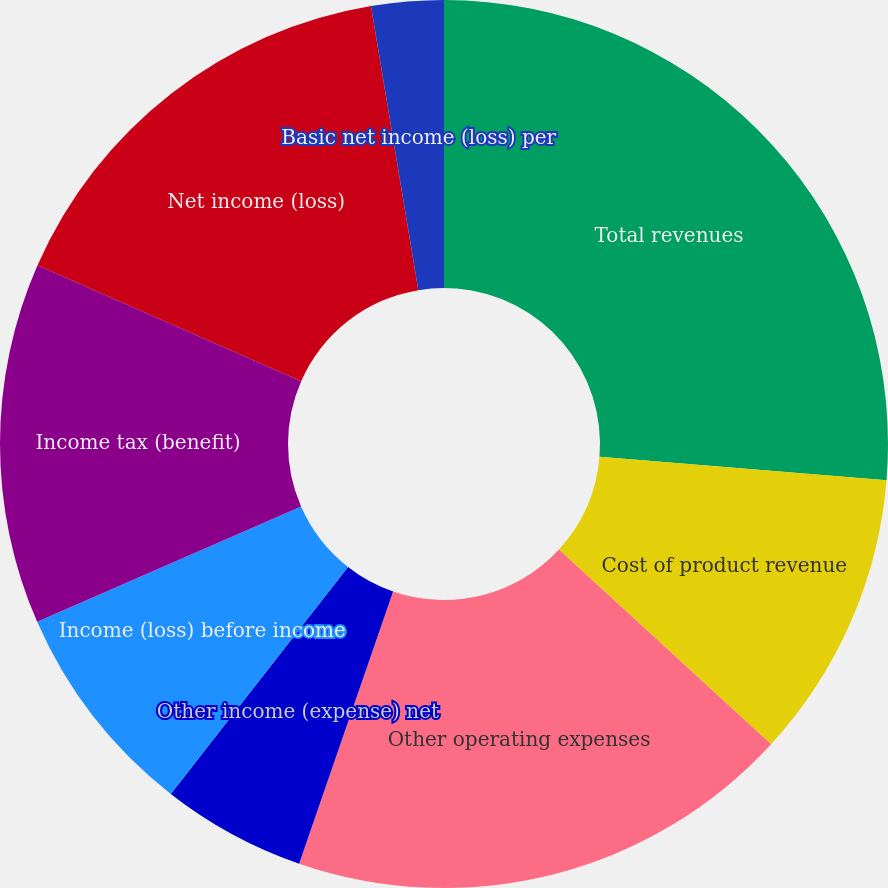Convert chart to OTSL. <chart><loc_0><loc_0><loc_500><loc_500><pie_chart><fcel>Total revenues<fcel>Cost of product revenue<fcel>Other operating expenses<fcel>Other income (expense) net<fcel>Income (loss) before income<fcel>Income tax (benefit)<fcel>Net income (loss)<fcel>Basic net income (loss) per<fcel>Diluted net income (loss) per<nl><fcel>26.3%<fcel>10.52%<fcel>18.47%<fcel>5.26%<fcel>7.89%<fcel>13.15%<fcel>15.78%<fcel>2.63%<fcel>0.0%<nl></chart> 